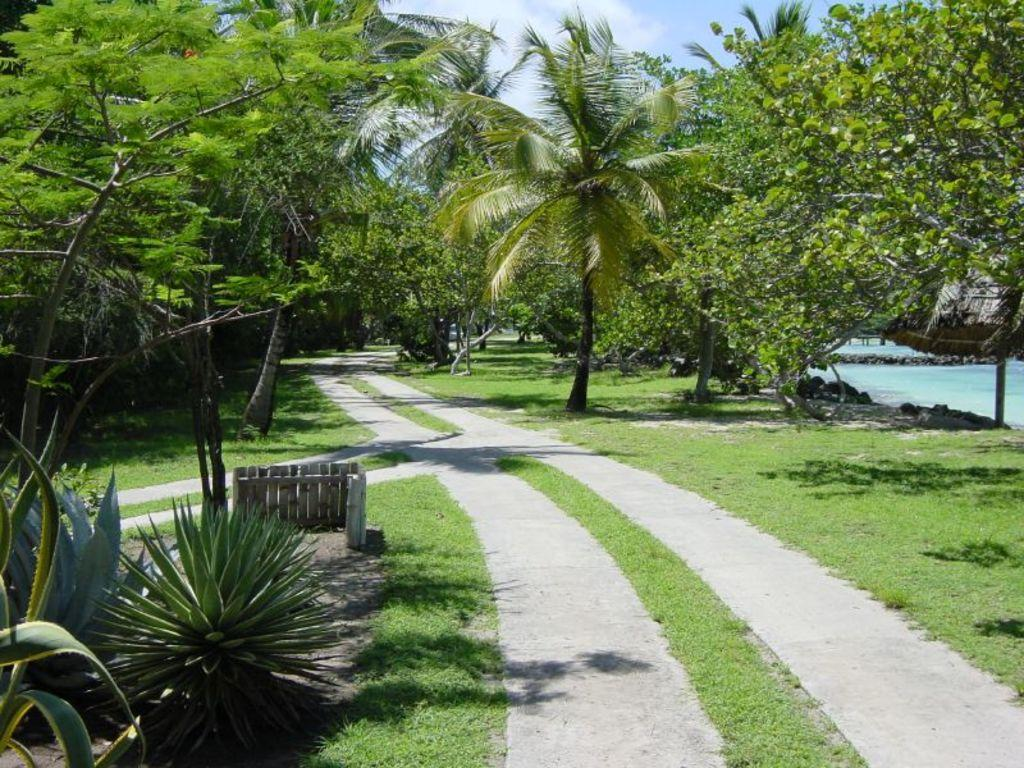What type of vegetation can be seen in the image? There are trees and plants in the image. Is there any indication of a path or trail in the image? Yes, there is a path between the trees in the image. What can be seen on the right side of the image? Water is visible on the right side of the image. What is visible at the top of the image? The sky is visible at the top of the image. How many cats can be seen playing with toes in the image? There are no cats visible in the image. 